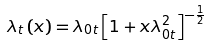Convert formula to latex. <formula><loc_0><loc_0><loc_500><loc_500>\lambda _ { t } \left ( x \right ) = \lambda _ { 0 t } \left [ 1 + x \lambda _ { 0 t } ^ { 2 } \right ] ^ { - \frac { 1 } { 2 } }</formula> 